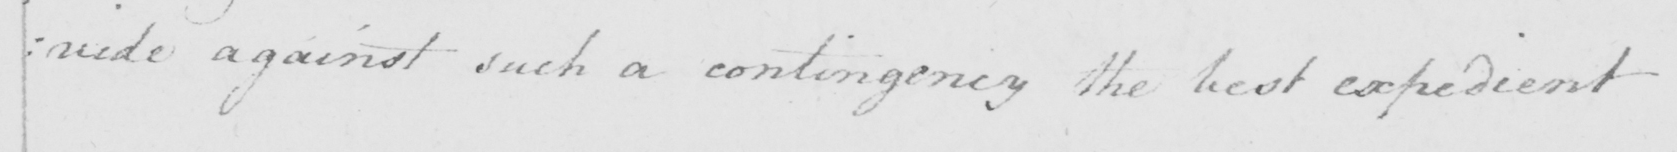Can you tell me what this handwritten text says? : vide against such a contingency the best expedient 